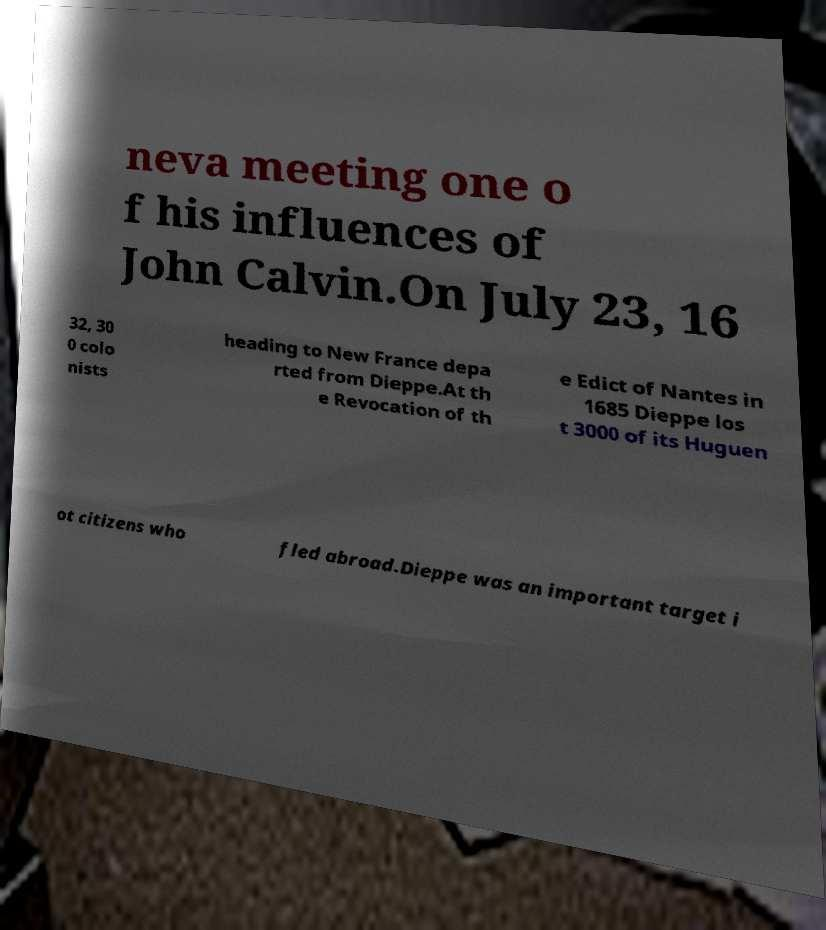Please identify and transcribe the text found in this image. neva meeting one o f his influences of John Calvin.On July 23, 16 32, 30 0 colo nists heading to New France depa rted from Dieppe.At th e Revocation of th e Edict of Nantes in 1685 Dieppe los t 3000 of its Huguen ot citizens who fled abroad.Dieppe was an important target i 